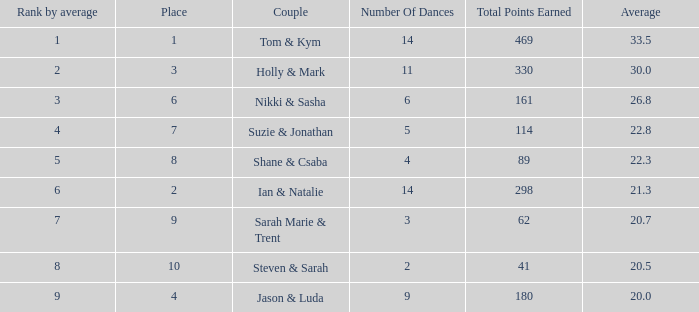3? 1.0. 